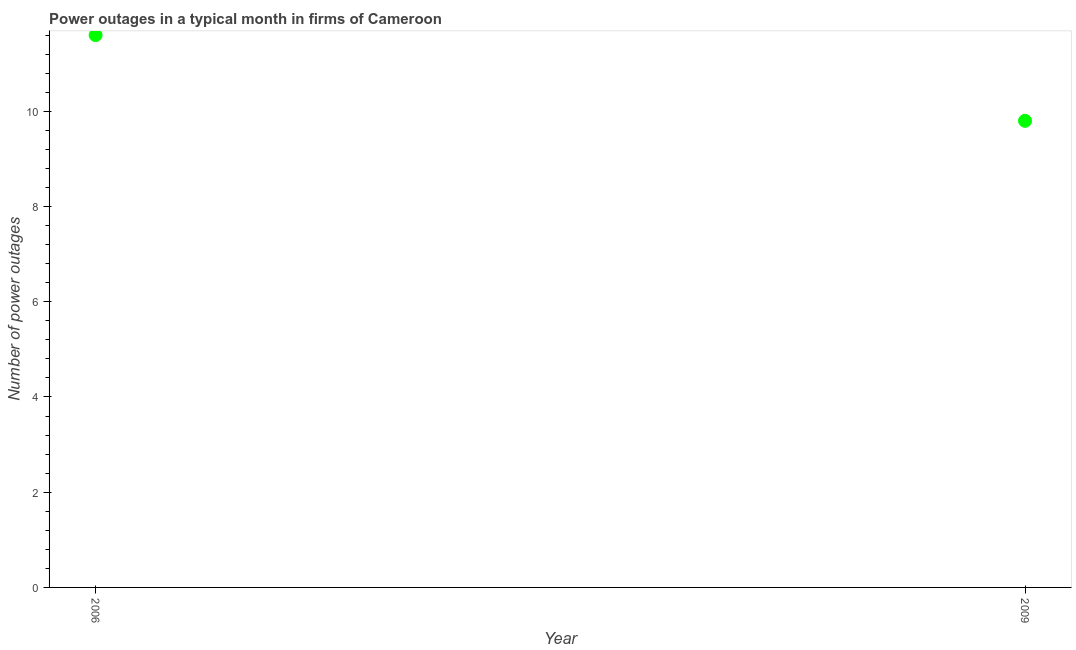What is the number of power outages in 2006?
Your response must be concise. 11.6. Across all years, what is the maximum number of power outages?
Your response must be concise. 11.6. Across all years, what is the minimum number of power outages?
Offer a terse response. 9.8. In which year was the number of power outages maximum?
Your response must be concise. 2006. In which year was the number of power outages minimum?
Your answer should be very brief. 2009. What is the sum of the number of power outages?
Provide a short and direct response. 21.4. What is the difference between the number of power outages in 2006 and 2009?
Provide a succinct answer. 1.8. What is the ratio of the number of power outages in 2006 to that in 2009?
Offer a terse response. 1.18. In how many years, is the number of power outages greater than the average number of power outages taken over all years?
Provide a succinct answer. 1. Does the number of power outages monotonically increase over the years?
Make the answer very short. No. How many dotlines are there?
Keep it short and to the point. 1. Does the graph contain any zero values?
Provide a short and direct response. No. What is the title of the graph?
Offer a terse response. Power outages in a typical month in firms of Cameroon. What is the label or title of the X-axis?
Give a very brief answer. Year. What is the label or title of the Y-axis?
Provide a succinct answer. Number of power outages. What is the Number of power outages in 2006?
Your response must be concise. 11.6. What is the Number of power outages in 2009?
Give a very brief answer. 9.8. What is the difference between the Number of power outages in 2006 and 2009?
Your answer should be compact. 1.8. What is the ratio of the Number of power outages in 2006 to that in 2009?
Offer a very short reply. 1.18. 